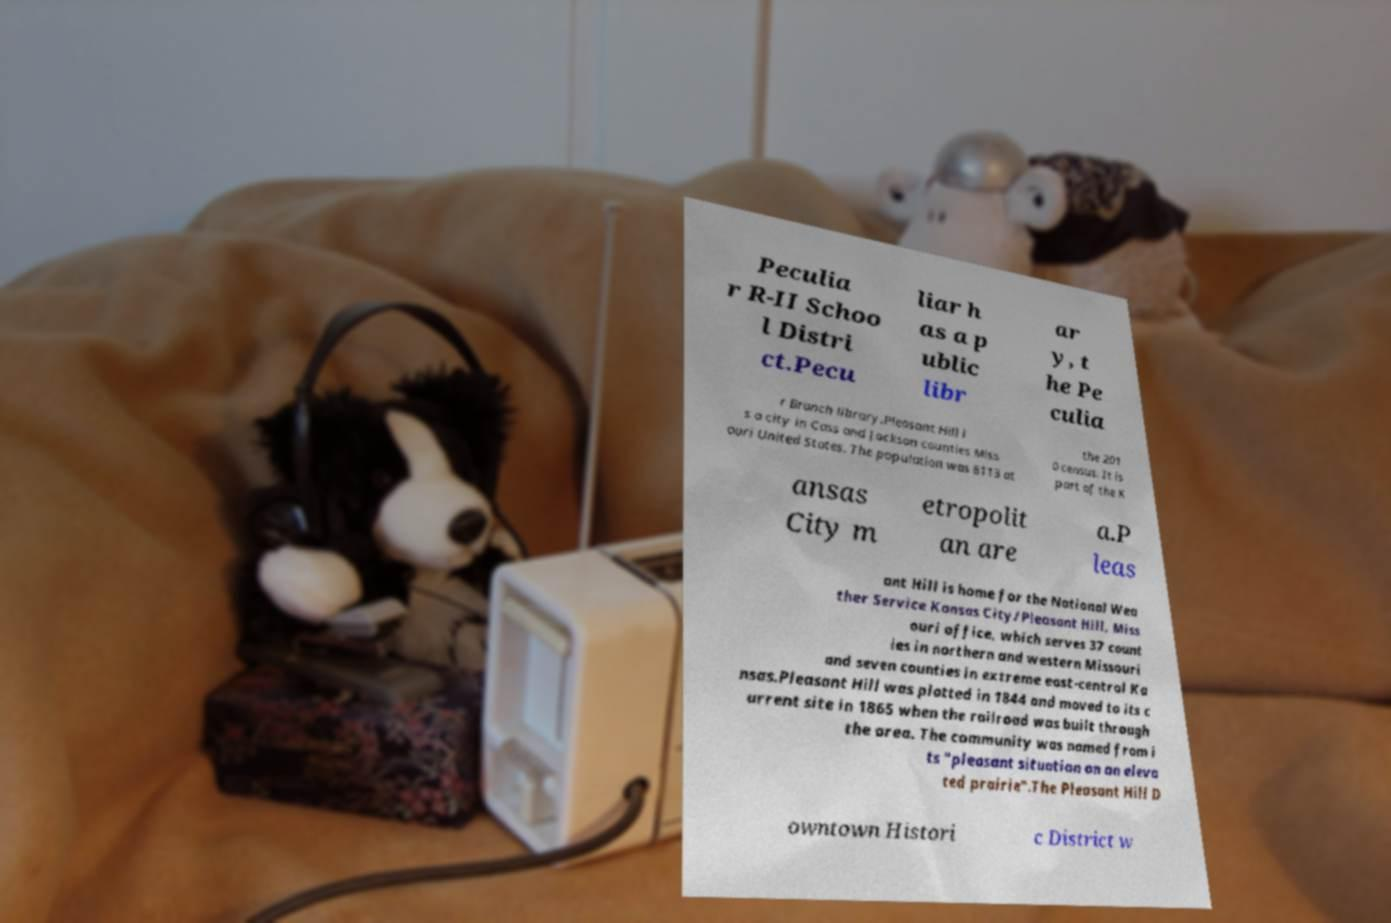There's text embedded in this image that I need extracted. Can you transcribe it verbatim? Peculia r R-II Schoo l Distri ct.Pecu liar h as a p ublic libr ar y, t he Pe culia r Branch library.Pleasant Hill i s a city in Cass and Jackson counties Miss ouri United States. The population was 8113 at the 201 0 census. It is part of the K ansas City m etropolit an are a.P leas ant Hill is home for the National Wea ther Service Kansas City/Pleasant Hill, Miss ouri office, which serves 37 count ies in northern and western Missouri and seven counties in extreme east-central Ka nsas.Pleasant Hill was platted in 1844 and moved to its c urrent site in 1865 when the railroad was built through the area. The community was named from i ts "pleasant situation on an eleva ted prairie".The Pleasant Hill D owntown Histori c District w 